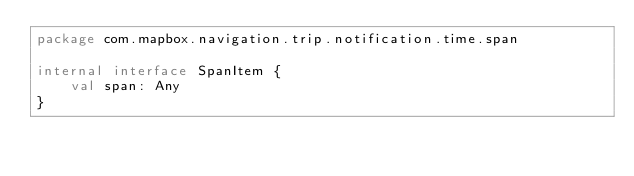Convert code to text. <code><loc_0><loc_0><loc_500><loc_500><_Kotlin_>package com.mapbox.navigation.trip.notification.time.span

internal interface SpanItem {
    val span: Any
}
</code> 